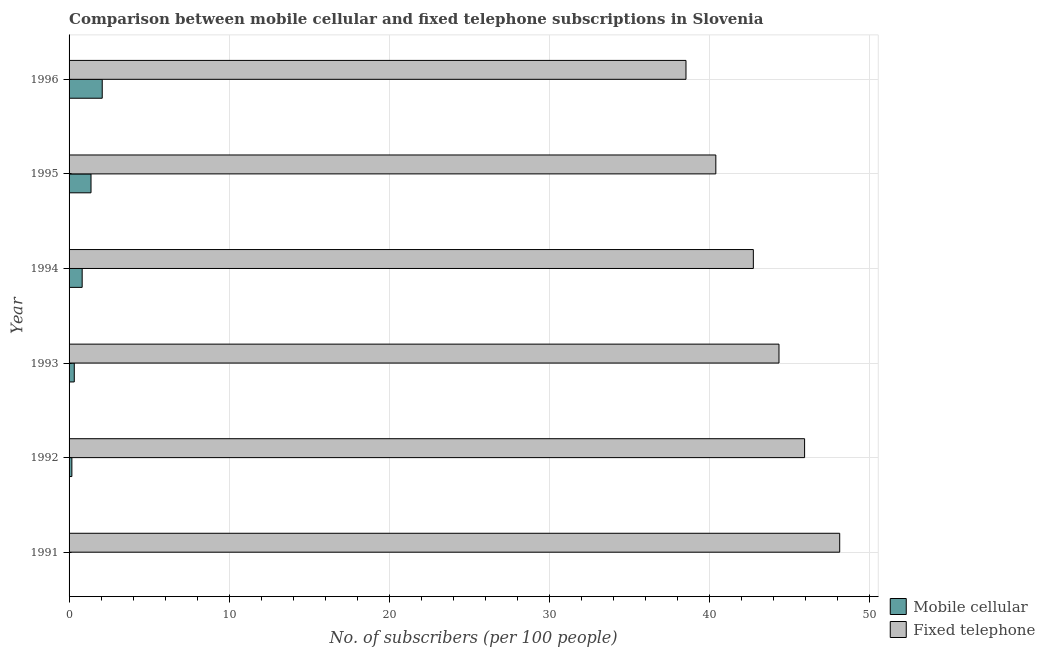How many different coloured bars are there?
Your answer should be compact. 2. Are the number of bars per tick equal to the number of legend labels?
Keep it short and to the point. Yes. Are the number of bars on each tick of the Y-axis equal?
Your answer should be very brief. Yes. What is the label of the 6th group of bars from the top?
Keep it short and to the point. 1991. In how many cases, is the number of bars for a given year not equal to the number of legend labels?
Your answer should be very brief. 0. What is the number of fixed telephone subscribers in 1993?
Ensure brevity in your answer.  44.34. Across all years, what is the maximum number of mobile cellular subscribers?
Give a very brief answer. 2.07. Across all years, what is the minimum number of fixed telephone subscribers?
Your answer should be compact. 38.53. In which year was the number of fixed telephone subscribers maximum?
Your response must be concise. 1991. In which year was the number of mobile cellular subscribers minimum?
Offer a terse response. 1991. What is the total number of mobile cellular subscribers in the graph?
Your answer should be compact. 4.79. What is the difference between the number of mobile cellular subscribers in 1993 and that in 1996?
Offer a very short reply. -1.75. What is the difference between the number of mobile cellular subscribers in 1993 and the number of fixed telephone subscribers in 1991?
Your answer should be compact. -47.81. What is the average number of fixed telephone subscribers per year?
Your response must be concise. 43.35. In the year 1992, what is the difference between the number of fixed telephone subscribers and number of mobile cellular subscribers?
Your response must be concise. 45.76. What is the ratio of the number of fixed telephone subscribers in 1992 to that in 1994?
Make the answer very short. 1.07. What does the 2nd bar from the top in 1993 represents?
Give a very brief answer. Mobile cellular. What does the 2nd bar from the bottom in 1996 represents?
Your answer should be very brief. Fixed telephone. What is the difference between two consecutive major ticks on the X-axis?
Make the answer very short. 10. Are the values on the major ticks of X-axis written in scientific E-notation?
Offer a terse response. No. Does the graph contain grids?
Your answer should be very brief. Yes. How are the legend labels stacked?
Ensure brevity in your answer.  Vertical. What is the title of the graph?
Your answer should be very brief. Comparison between mobile cellular and fixed telephone subscriptions in Slovenia. Does "Male population" appear as one of the legend labels in the graph?
Your response must be concise. No. What is the label or title of the X-axis?
Your answer should be very brief. No. of subscribers (per 100 people). What is the No. of subscribers (per 100 people) of Mobile cellular in 1991?
Keep it short and to the point. 0.03. What is the No. of subscribers (per 100 people) in Fixed telephone in 1991?
Make the answer very short. 48.13. What is the No. of subscribers (per 100 people) in Mobile cellular in 1992?
Ensure brevity in your answer.  0.17. What is the No. of subscribers (per 100 people) of Fixed telephone in 1992?
Give a very brief answer. 45.94. What is the No. of subscribers (per 100 people) in Mobile cellular in 1993?
Ensure brevity in your answer.  0.33. What is the No. of subscribers (per 100 people) in Fixed telephone in 1993?
Your answer should be very brief. 44.34. What is the No. of subscribers (per 100 people) in Mobile cellular in 1994?
Make the answer very short. 0.82. What is the No. of subscribers (per 100 people) in Fixed telephone in 1994?
Ensure brevity in your answer.  42.74. What is the No. of subscribers (per 100 people) in Mobile cellular in 1995?
Provide a short and direct response. 1.37. What is the No. of subscribers (per 100 people) in Fixed telephone in 1995?
Your response must be concise. 40.4. What is the No. of subscribers (per 100 people) of Mobile cellular in 1996?
Your answer should be very brief. 2.07. What is the No. of subscribers (per 100 people) of Fixed telephone in 1996?
Ensure brevity in your answer.  38.53. Across all years, what is the maximum No. of subscribers (per 100 people) of Mobile cellular?
Offer a very short reply. 2.07. Across all years, what is the maximum No. of subscribers (per 100 people) of Fixed telephone?
Offer a terse response. 48.13. Across all years, what is the minimum No. of subscribers (per 100 people) of Mobile cellular?
Make the answer very short. 0.03. Across all years, what is the minimum No. of subscribers (per 100 people) in Fixed telephone?
Offer a terse response. 38.53. What is the total No. of subscribers (per 100 people) in Mobile cellular in the graph?
Provide a succinct answer. 4.79. What is the total No. of subscribers (per 100 people) in Fixed telephone in the graph?
Your answer should be compact. 260.07. What is the difference between the No. of subscribers (per 100 people) in Mobile cellular in 1991 and that in 1992?
Your answer should be compact. -0.15. What is the difference between the No. of subscribers (per 100 people) in Fixed telephone in 1991 and that in 1992?
Give a very brief answer. 2.19. What is the difference between the No. of subscribers (per 100 people) in Mobile cellular in 1991 and that in 1993?
Ensure brevity in your answer.  -0.3. What is the difference between the No. of subscribers (per 100 people) in Fixed telephone in 1991 and that in 1993?
Offer a terse response. 3.79. What is the difference between the No. of subscribers (per 100 people) in Mobile cellular in 1991 and that in 1994?
Provide a succinct answer. -0.79. What is the difference between the No. of subscribers (per 100 people) in Fixed telephone in 1991 and that in 1994?
Ensure brevity in your answer.  5.39. What is the difference between the No. of subscribers (per 100 people) of Mobile cellular in 1991 and that in 1995?
Offer a very short reply. -1.34. What is the difference between the No. of subscribers (per 100 people) in Fixed telephone in 1991 and that in 1995?
Your answer should be very brief. 7.74. What is the difference between the No. of subscribers (per 100 people) of Mobile cellular in 1991 and that in 1996?
Your answer should be compact. -2.04. What is the difference between the No. of subscribers (per 100 people) in Fixed telephone in 1991 and that in 1996?
Keep it short and to the point. 9.6. What is the difference between the No. of subscribers (per 100 people) in Mobile cellular in 1992 and that in 1993?
Make the answer very short. -0.15. What is the difference between the No. of subscribers (per 100 people) in Fixed telephone in 1992 and that in 1993?
Ensure brevity in your answer.  1.6. What is the difference between the No. of subscribers (per 100 people) in Mobile cellular in 1992 and that in 1994?
Provide a succinct answer. -0.64. What is the difference between the No. of subscribers (per 100 people) in Fixed telephone in 1992 and that in 1994?
Keep it short and to the point. 3.2. What is the difference between the No. of subscribers (per 100 people) in Mobile cellular in 1992 and that in 1995?
Keep it short and to the point. -1.2. What is the difference between the No. of subscribers (per 100 people) in Fixed telephone in 1992 and that in 1995?
Give a very brief answer. 5.54. What is the difference between the No. of subscribers (per 100 people) in Mobile cellular in 1992 and that in 1996?
Your answer should be very brief. -1.9. What is the difference between the No. of subscribers (per 100 people) of Fixed telephone in 1992 and that in 1996?
Your answer should be compact. 7.41. What is the difference between the No. of subscribers (per 100 people) in Mobile cellular in 1993 and that in 1994?
Provide a short and direct response. -0.49. What is the difference between the No. of subscribers (per 100 people) of Fixed telephone in 1993 and that in 1994?
Provide a short and direct response. 1.6. What is the difference between the No. of subscribers (per 100 people) of Mobile cellular in 1993 and that in 1995?
Keep it short and to the point. -1.05. What is the difference between the No. of subscribers (per 100 people) of Fixed telephone in 1993 and that in 1995?
Ensure brevity in your answer.  3.94. What is the difference between the No. of subscribers (per 100 people) of Mobile cellular in 1993 and that in 1996?
Your response must be concise. -1.75. What is the difference between the No. of subscribers (per 100 people) of Fixed telephone in 1993 and that in 1996?
Your response must be concise. 5.81. What is the difference between the No. of subscribers (per 100 people) of Mobile cellular in 1994 and that in 1995?
Offer a terse response. -0.55. What is the difference between the No. of subscribers (per 100 people) in Fixed telephone in 1994 and that in 1995?
Offer a very short reply. 2.34. What is the difference between the No. of subscribers (per 100 people) in Mobile cellular in 1994 and that in 1996?
Offer a terse response. -1.25. What is the difference between the No. of subscribers (per 100 people) in Fixed telephone in 1994 and that in 1996?
Offer a very short reply. 4.21. What is the difference between the No. of subscribers (per 100 people) of Mobile cellular in 1995 and that in 1996?
Offer a very short reply. -0.7. What is the difference between the No. of subscribers (per 100 people) in Fixed telephone in 1995 and that in 1996?
Your answer should be compact. 1.86. What is the difference between the No. of subscribers (per 100 people) in Mobile cellular in 1991 and the No. of subscribers (per 100 people) in Fixed telephone in 1992?
Your answer should be compact. -45.91. What is the difference between the No. of subscribers (per 100 people) in Mobile cellular in 1991 and the No. of subscribers (per 100 people) in Fixed telephone in 1993?
Provide a succinct answer. -44.31. What is the difference between the No. of subscribers (per 100 people) of Mobile cellular in 1991 and the No. of subscribers (per 100 people) of Fixed telephone in 1994?
Give a very brief answer. -42.71. What is the difference between the No. of subscribers (per 100 people) of Mobile cellular in 1991 and the No. of subscribers (per 100 people) of Fixed telephone in 1995?
Offer a terse response. -40.37. What is the difference between the No. of subscribers (per 100 people) in Mobile cellular in 1991 and the No. of subscribers (per 100 people) in Fixed telephone in 1996?
Ensure brevity in your answer.  -38.5. What is the difference between the No. of subscribers (per 100 people) in Mobile cellular in 1992 and the No. of subscribers (per 100 people) in Fixed telephone in 1993?
Give a very brief answer. -44.16. What is the difference between the No. of subscribers (per 100 people) in Mobile cellular in 1992 and the No. of subscribers (per 100 people) in Fixed telephone in 1994?
Provide a short and direct response. -42.56. What is the difference between the No. of subscribers (per 100 people) of Mobile cellular in 1992 and the No. of subscribers (per 100 people) of Fixed telephone in 1995?
Provide a succinct answer. -40.22. What is the difference between the No. of subscribers (per 100 people) of Mobile cellular in 1992 and the No. of subscribers (per 100 people) of Fixed telephone in 1996?
Offer a very short reply. -38.36. What is the difference between the No. of subscribers (per 100 people) of Mobile cellular in 1993 and the No. of subscribers (per 100 people) of Fixed telephone in 1994?
Offer a terse response. -42.41. What is the difference between the No. of subscribers (per 100 people) of Mobile cellular in 1993 and the No. of subscribers (per 100 people) of Fixed telephone in 1995?
Make the answer very short. -40.07. What is the difference between the No. of subscribers (per 100 people) of Mobile cellular in 1993 and the No. of subscribers (per 100 people) of Fixed telephone in 1996?
Offer a very short reply. -38.21. What is the difference between the No. of subscribers (per 100 people) of Mobile cellular in 1994 and the No. of subscribers (per 100 people) of Fixed telephone in 1995?
Your response must be concise. -39.58. What is the difference between the No. of subscribers (per 100 people) of Mobile cellular in 1994 and the No. of subscribers (per 100 people) of Fixed telephone in 1996?
Your response must be concise. -37.71. What is the difference between the No. of subscribers (per 100 people) in Mobile cellular in 1995 and the No. of subscribers (per 100 people) in Fixed telephone in 1996?
Offer a very short reply. -37.16. What is the average No. of subscribers (per 100 people) in Mobile cellular per year?
Make the answer very short. 0.8. What is the average No. of subscribers (per 100 people) of Fixed telephone per year?
Offer a terse response. 43.35. In the year 1991, what is the difference between the No. of subscribers (per 100 people) of Mobile cellular and No. of subscribers (per 100 people) of Fixed telephone?
Provide a short and direct response. -48.11. In the year 1992, what is the difference between the No. of subscribers (per 100 people) in Mobile cellular and No. of subscribers (per 100 people) in Fixed telephone?
Make the answer very short. -45.76. In the year 1993, what is the difference between the No. of subscribers (per 100 people) of Mobile cellular and No. of subscribers (per 100 people) of Fixed telephone?
Keep it short and to the point. -44.01. In the year 1994, what is the difference between the No. of subscribers (per 100 people) of Mobile cellular and No. of subscribers (per 100 people) of Fixed telephone?
Provide a succinct answer. -41.92. In the year 1995, what is the difference between the No. of subscribers (per 100 people) of Mobile cellular and No. of subscribers (per 100 people) of Fixed telephone?
Offer a very short reply. -39.02. In the year 1996, what is the difference between the No. of subscribers (per 100 people) in Mobile cellular and No. of subscribers (per 100 people) in Fixed telephone?
Offer a terse response. -36.46. What is the ratio of the No. of subscribers (per 100 people) of Mobile cellular in 1991 to that in 1992?
Your answer should be very brief. 0.15. What is the ratio of the No. of subscribers (per 100 people) in Fixed telephone in 1991 to that in 1992?
Give a very brief answer. 1.05. What is the ratio of the No. of subscribers (per 100 people) in Mobile cellular in 1991 to that in 1993?
Ensure brevity in your answer.  0.08. What is the ratio of the No. of subscribers (per 100 people) of Fixed telephone in 1991 to that in 1993?
Give a very brief answer. 1.09. What is the ratio of the No. of subscribers (per 100 people) in Mobile cellular in 1991 to that in 1994?
Your answer should be compact. 0.03. What is the ratio of the No. of subscribers (per 100 people) of Fixed telephone in 1991 to that in 1994?
Provide a short and direct response. 1.13. What is the ratio of the No. of subscribers (per 100 people) in Mobile cellular in 1991 to that in 1995?
Offer a very short reply. 0.02. What is the ratio of the No. of subscribers (per 100 people) of Fixed telephone in 1991 to that in 1995?
Offer a very short reply. 1.19. What is the ratio of the No. of subscribers (per 100 people) of Mobile cellular in 1991 to that in 1996?
Give a very brief answer. 0.01. What is the ratio of the No. of subscribers (per 100 people) of Fixed telephone in 1991 to that in 1996?
Ensure brevity in your answer.  1.25. What is the ratio of the No. of subscribers (per 100 people) of Mobile cellular in 1992 to that in 1993?
Make the answer very short. 0.54. What is the ratio of the No. of subscribers (per 100 people) of Fixed telephone in 1992 to that in 1993?
Make the answer very short. 1.04. What is the ratio of the No. of subscribers (per 100 people) of Mobile cellular in 1992 to that in 1994?
Provide a succinct answer. 0.21. What is the ratio of the No. of subscribers (per 100 people) of Fixed telephone in 1992 to that in 1994?
Provide a short and direct response. 1.07. What is the ratio of the No. of subscribers (per 100 people) of Mobile cellular in 1992 to that in 1995?
Ensure brevity in your answer.  0.13. What is the ratio of the No. of subscribers (per 100 people) in Fixed telephone in 1992 to that in 1995?
Your answer should be very brief. 1.14. What is the ratio of the No. of subscribers (per 100 people) in Mobile cellular in 1992 to that in 1996?
Provide a short and direct response. 0.08. What is the ratio of the No. of subscribers (per 100 people) in Fixed telephone in 1992 to that in 1996?
Offer a very short reply. 1.19. What is the ratio of the No. of subscribers (per 100 people) of Mobile cellular in 1993 to that in 1994?
Provide a succinct answer. 0.4. What is the ratio of the No. of subscribers (per 100 people) of Fixed telephone in 1993 to that in 1994?
Provide a short and direct response. 1.04. What is the ratio of the No. of subscribers (per 100 people) in Mobile cellular in 1993 to that in 1995?
Keep it short and to the point. 0.24. What is the ratio of the No. of subscribers (per 100 people) in Fixed telephone in 1993 to that in 1995?
Your response must be concise. 1.1. What is the ratio of the No. of subscribers (per 100 people) in Mobile cellular in 1993 to that in 1996?
Provide a succinct answer. 0.16. What is the ratio of the No. of subscribers (per 100 people) of Fixed telephone in 1993 to that in 1996?
Your response must be concise. 1.15. What is the ratio of the No. of subscribers (per 100 people) of Mobile cellular in 1994 to that in 1995?
Make the answer very short. 0.6. What is the ratio of the No. of subscribers (per 100 people) of Fixed telephone in 1994 to that in 1995?
Make the answer very short. 1.06. What is the ratio of the No. of subscribers (per 100 people) in Mobile cellular in 1994 to that in 1996?
Provide a succinct answer. 0.4. What is the ratio of the No. of subscribers (per 100 people) of Fixed telephone in 1994 to that in 1996?
Keep it short and to the point. 1.11. What is the ratio of the No. of subscribers (per 100 people) of Mobile cellular in 1995 to that in 1996?
Provide a short and direct response. 0.66. What is the ratio of the No. of subscribers (per 100 people) in Fixed telephone in 1995 to that in 1996?
Provide a succinct answer. 1.05. What is the difference between the highest and the second highest No. of subscribers (per 100 people) in Mobile cellular?
Your answer should be very brief. 0.7. What is the difference between the highest and the second highest No. of subscribers (per 100 people) of Fixed telephone?
Your response must be concise. 2.19. What is the difference between the highest and the lowest No. of subscribers (per 100 people) of Mobile cellular?
Offer a very short reply. 2.04. What is the difference between the highest and the lowest No. of subscribers (per 100 people) of Fixed telephone?
Your answer should be compact. 9.6. 